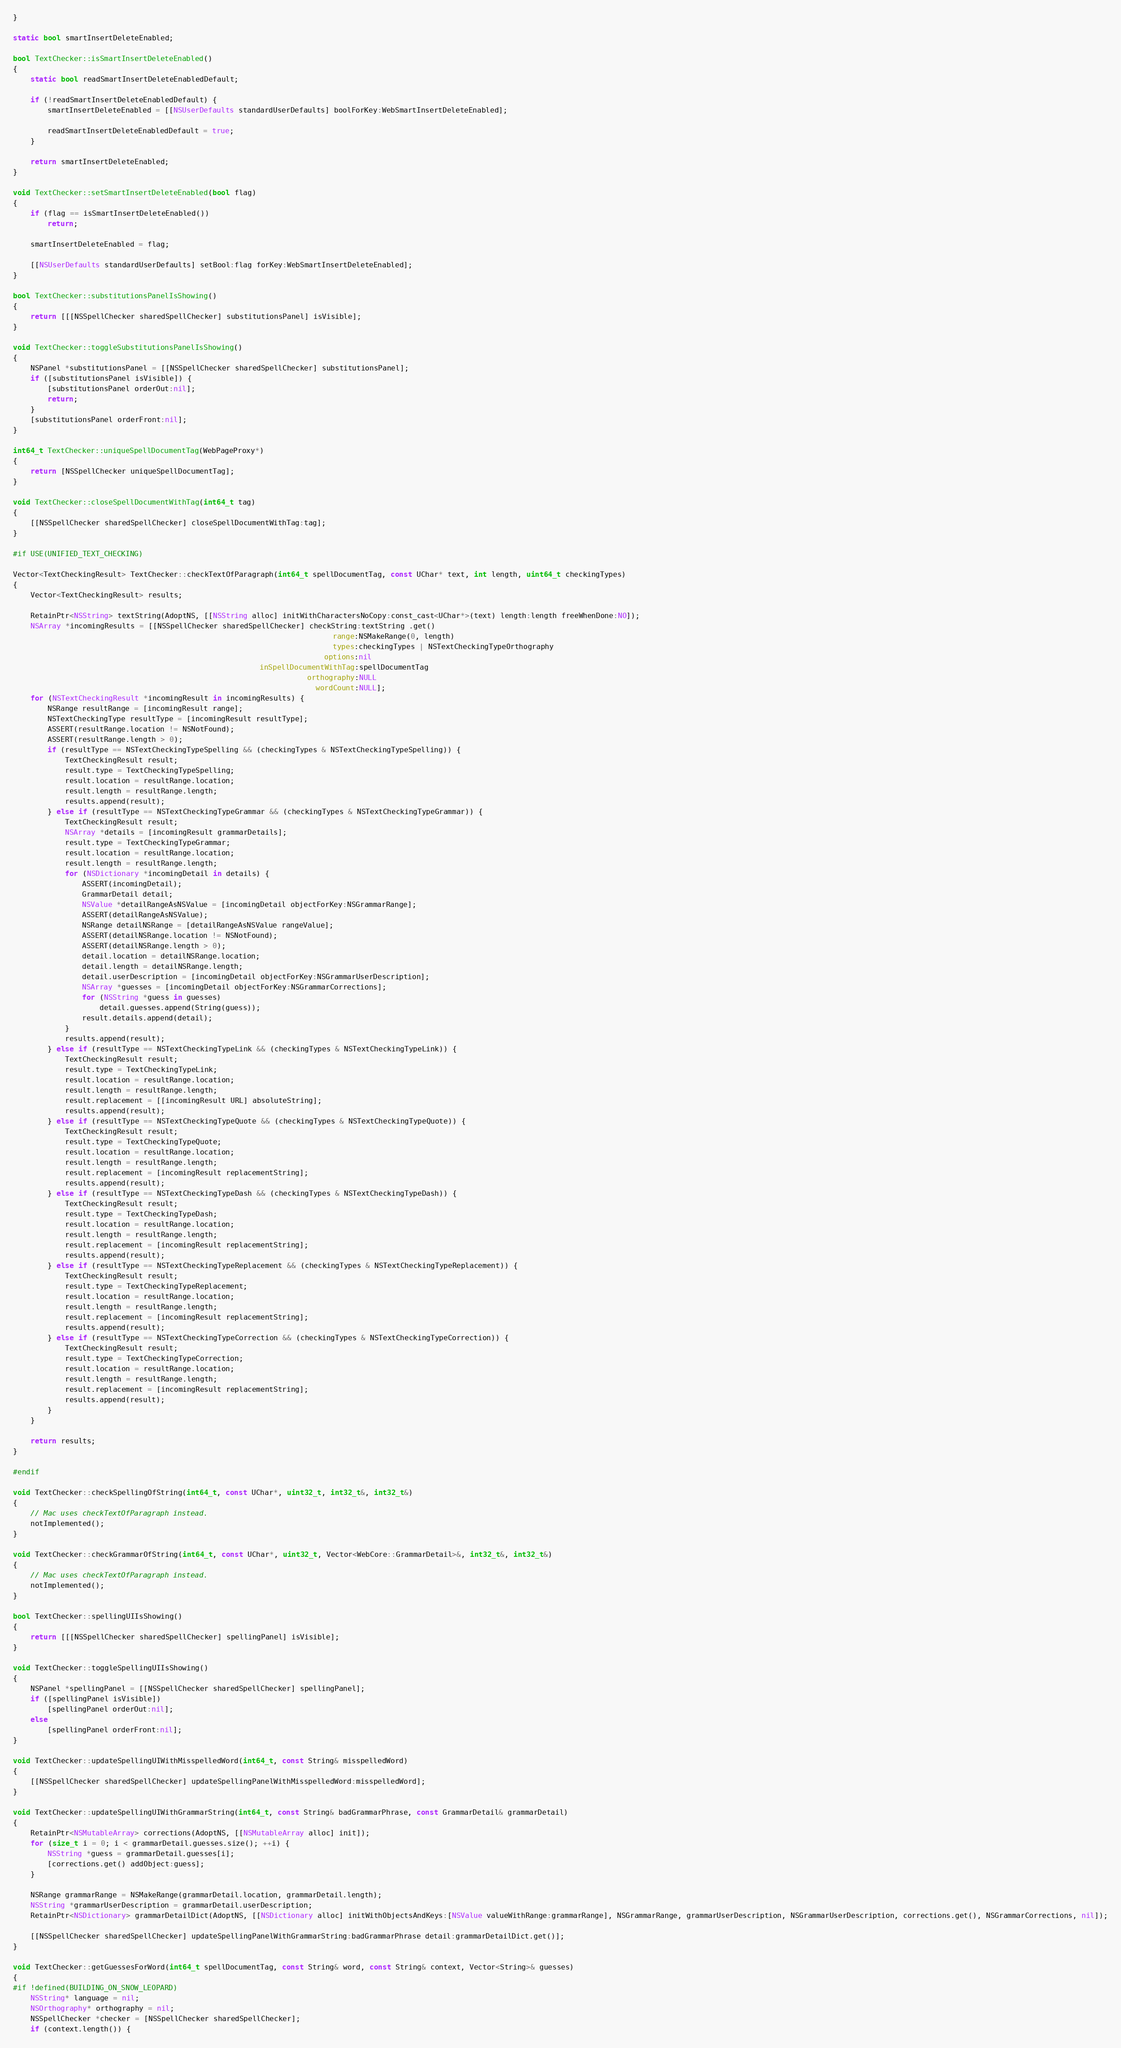Convert code to text. <code><loc_0><loc_0><loc_500><loc_500><_ObjectiveC_>}

static bool smartInsertDeleteEnabled;
    
bool TextChecker::isSmartInsertDeleteEnabled()
{
    static bool readSmartInsertDeleteEnabledDefault;

    if (!readSmartInsertDeleteEnabledDefault) {
        smartInsertDeleteEnabled = [[NSUserDefaults standardUserDefaults] boolForKey:WebSmartInsertDeleteEnabled];

        readSmartInsertDeleteEnabledDefault = true;
    }

    return smartInsertDeleteEnabled;
}

void TextChecker::setSmartInsertDeleteEnabled(bool flag)
{
    if (flag == isSmartInsertDeleteEnabled())
        return;

    smartInsertDeleteEnabled = flag;

    [[NSUserDefaults standardUserDefaults] setBool:flag forKey:WebSmartInsertDeleteEnabled];
}

bool TextChecker::substitutionsPanelIsShowing()
{
    return [[[NSSpellChecker sharedSpellChecker] substitutionsPanel] isVisible];
}

void TextChecker::toggleSubstitutionsPanelIsShowing()
{
    NSPanel *substitutionsPanel = [[NSSpellChecker sharedSpellChecker] substitutionsPanel];
    if ([substitutionsPanel isVisible]) {
        [substitutionsPanel orderOut:nil];
        return;
    }
    [substitutionsPanel orderFront:nil];
}

int64_t TextChecker::uniqueSpellDocumentTag(WebPageProxy*)
{
    return [NSSpellChecker uniqueSpellDocumentTag];
}

void TextChecker::closeSpellDocumentWithTag(int64_t tag)
{
    [[NSSpellChecker sharedSpellChecker] closeSpellDocumentWithTag:tag];
}

#if USE(UNIFIED_TEXT_CHECKING)

Vector<TextCheckingResult> TextChecker::checkTextOfParagraph(int64_t spellDocumentTag, const UChar* text, int length, uint64_t checkingTypes)
{
    Vector<TextCheckingResult> results;

    RetainPtr<NSString> textString(AdoptNS, [[NSString alloc] initWithCharactersNoCopy:const_cast<UChar*>(text) length:length freeWhenDone:NO]);
    NSArray *incomingResults = [[NSSpellChecker sharedSpellChecker] checkString:textString .get()
                                                                          range:NSMakeRange(0, length)
                                                                          types:checkingTypes | NSTextCheckingTypeOrthography
                                                                        options:nil
                                                         inSpellDocumentWithTag:spellDocumentTag 
                                                                    orthography:NULL
                                                                      wordCount:NULL];
    for (NSTextCheckingResult *incomingResult in incomingResults) {
        NSRange resultRange = [incomingResult range];
        NSTextCheckingType resultType = [incomingResult resultType];
        ASSERT(resultRange.location != NSNotFound);
        ASSERT(resultRange.length > 0);
        if (resultType == NSTextCheckingTypeSpelling && (checkingTypes & NSTextCheckingTypeSpelling)) {
            TextCheckingResult result;
            result.type = TextCheckingTypeSpelling;
            result.location = resultRange.location;
            result.length = resultRange.length;
            results.append(result);
        } else if (resultType == NSTextCheckingTypeGrammar && (checkingTypes & NSTextCheckingTypeGrammar)) {
            TextCheckingResult result;
            NSArray *details = [incomingResult grammarDetails];
            result.type = TextCheckingTypeGrammar;
            result.location = resultRange.location;
            result.length = resultRange.length;
            for (NSDictionary *incomingDetail in details) {
                ASSERT(incomingDetail);
                GrammarDetail detail;
                NSValue *detailRangeAsNSValue = [incomingDetail objectForKey:NSGrammarRange];
                ASSERT(detailRangeAsNSValue);
                NSRange detailNSRange = [detailRangeAsNSValue rangeValue];
                ASSERT(detailNSRange.location != NSNotFound);
                ASSERT(detailNSRange.length > 0);
                detail.location = detailNSRange.location;
                detail.length = detailNSRange.length;
                detail.userDescription = [incomingDetail objectForKey:NSGrammarUserDescription];
                NSArray *guesses = [incomingDetail objectForKey:NSGrammarCorrections];
                for (NSString *guess in guesses)
                    detail.guesses.append(String(guess));
                result.details.append(detail);
            }
            results.append(result);
        } else if (resultType == NSTextCheckingTypeLink && (checkingTypes & NSTextCheckingTypeLink)) {
            TextCheckingResult result;
            result.type = TextCheckingTypeLink;
            result.location = resultRange.location;
            result.length = resultRange.length;
            result.replacement = [[incomingResult URL] absoluteString];
            results.append(result);
        } else if (resultType == NSTextCheckingTypeQuote && (checkingTypes & NSTextCheckingTypeQuote)) {
            TextCheckingResult result;
            result.type = TextCheckingTypeQuote;
            result.location = resultRange.location;
            result.length = resultRange.length;
            result.replacement = [incomingResult replacementString];
            results.append(result);
        } else if (resultType == NSTextCheckingTypeDash && (checkingTypes & NSTextCheckingTypeDash)) {
            TextCheckingResult result;
            result.type = TextCheckingTypeDash;
            result.location = resultRange.location;
            result.length = resultRange.length;
            result.replacement = [incomingResult replacementString];
            results.append(result);
        } else if (resultType == NSTextCheckingTypeReplacement && (checkingTypes & NSTextCheckingTypeReplacement)) {
            TextCheckingResult result;
            result.type = TextCheckingTypeReplacement;
            result.location = resultRange.location;
            result.length = resultRange.length;
            result.replacement = [incomingResult replacementString];
            results.append(result);
        } else if (resultType == NSTextCheckingTypeCorrection && (checkingTypes & NSTextCheckingTypeCorrection)) {
            TextCheckingResult result;
            result.type = TextCheckingTypeCorrection;
            result.location = resultRange.location;
            result.length = resultRange.length;
            result.replacement = [incomingResult replacementString];
            results.append(result);
        }
    }

    return results;
}

#endif

void TextChecker::checkSpellingOfString(int64_t, const UChar*, uint32_t, int32_t&, int32_t&)
{
    // Mac uses checkTextOfParagraph instead.
    notImplemented();
}

void TextChecker::checkGrammarOfString(int64_t, const UChar*, uint32_t, Vector<WebCore::GrammarDetail>&, int32_t&, int32_t&)
{
    // Mac uses checkTextOfParagraph instead.
    notImplemented();
}

bool TextChecker::spellingUIIsShowing()
{
    return [[[NSSpellChecker sharedSpellChecker] spellingPanel] isVisible];
}

void TextChecker::toggleSpellingUIIsShowing()
{
    NSPanel *spellingPanel = [[NSSpellChecker sharedSpellChecker] spellingPanel];
    if ([spellingPanel isVisible])
        [spellingPanel orderOut:nil];
    else
        [spellingPanel orderFront:nil];
}

void TextChecker::updateSpellingUIWithMisspelledWord(int64_t, const String& misspelledWord)
{
    [[NSSpellChecker sharedSpellChecker] updateSpellingPanelWithMisspelledWord:misspelledWord];
}

void TextChecker::updateSpellingUIWithGrammarString(int64_t, const String& badGrammarPhrase, const GrammarDetail& grammarDetail)
{
    RetainPtr<NSMutableArray> corrections(AdoptNS, [[NSMutableArray alloc] init]);
    for (size_t i = 0; i < grammarDetail.guesses.size(); ++i) {
        NSString *guess = grammarDetail.guesses[i];
        [corrections.get() addObject:guess];
    }

    NSRange grammarRange = NSMakeRange(grammarDetail.location, grammarDetail.length);
    NSString *grammarUserDescription = grammarDetail.userDescription;
    RetainPtr<NSDictionary> grammarDetailDict(AdoptNS, [[NSDictionary alloc] initWithObjectsAndKeys:[NSValue valueWithRange:grammarRange], NSGrammarRange, grammarUserDescription, NSGrammarUserDescription, corrections.get(), NSGrammarCorrections, nil]);

    [[NSSpellChecker sharedSpellChecker] updateSpellingPanelWithGrammarString:badGrammarPhrase detail:grammarDetailDict.get()];
}

void TextChecker::getGuessesForWord(int64_t spellDocumentTag, const String& word, const String& context, Vector<String>& guesses)
{
#if !defined(BUILDING_ON_SNOW_LEOPARD)
    NSString* language = nil;
    NSOrthography* orthography = nil;
    NSSpellChecker *checker = [NSSpellChecker sharedSpellChecker];
    if (context.length()) {</code> 